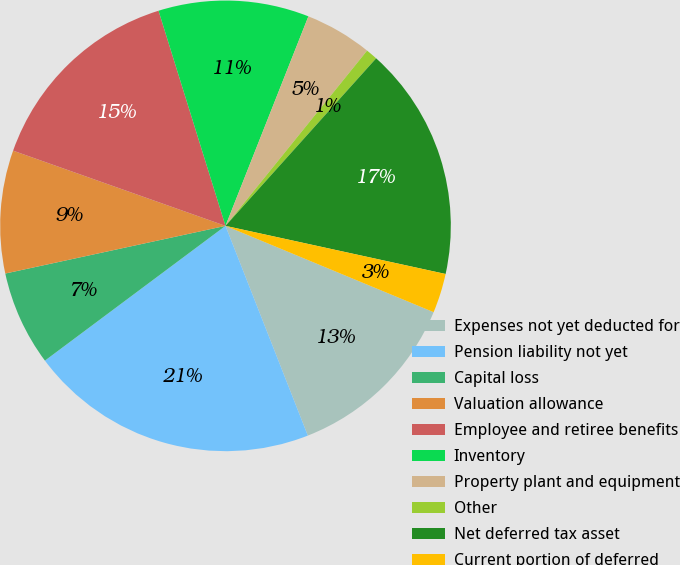<chart> <loc_0><loc_0><loc_500><loc_500><pie_chart><fcel>Expenses not yet deducted for<fcel>Pension liability not yet<fcel>Capital loss<fcel>Valuation allowance<fcel>Employee and retiree benefits<fcel>Inventory<fcel>Property plant and equipment<fcel>Other<fcel>Net deferred tax asset<fcel>Current portion of deferred<nl><fcel>12.79%<fcel>20.75%<fcel>6.81%<fcel>8.81%<fcel>14.78%<fcel>10.8%<fcel>4.82%<fcel>0.84%<fcel>16.77%<fcel>2.83%<nl></chart> 